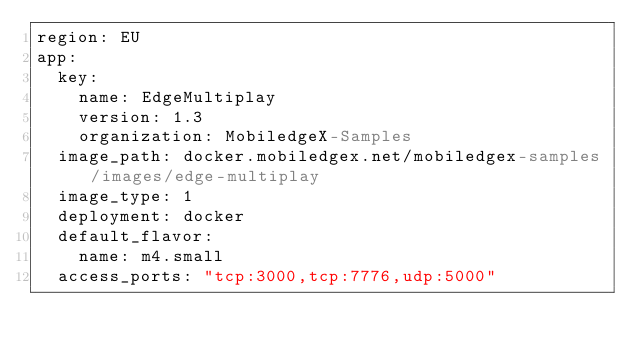Convert code to text. <code><loc_0><loc_0><loc_500><loc_500><_YAML_>region: EU
app: 
  key: 
    name: EdgeMultiplay
    version: 1.3
    organization: MobiledgeX-Samples
  image_path: docker.mobiledgex.net/mobiledgex-samples/images/edge-multiplay
  image_type: 1
  deployment: docker
  default_flavor: 
    name: m4.small
  access_ports: "tcp:3000,tcp:7776,udp:5000"
</code> 